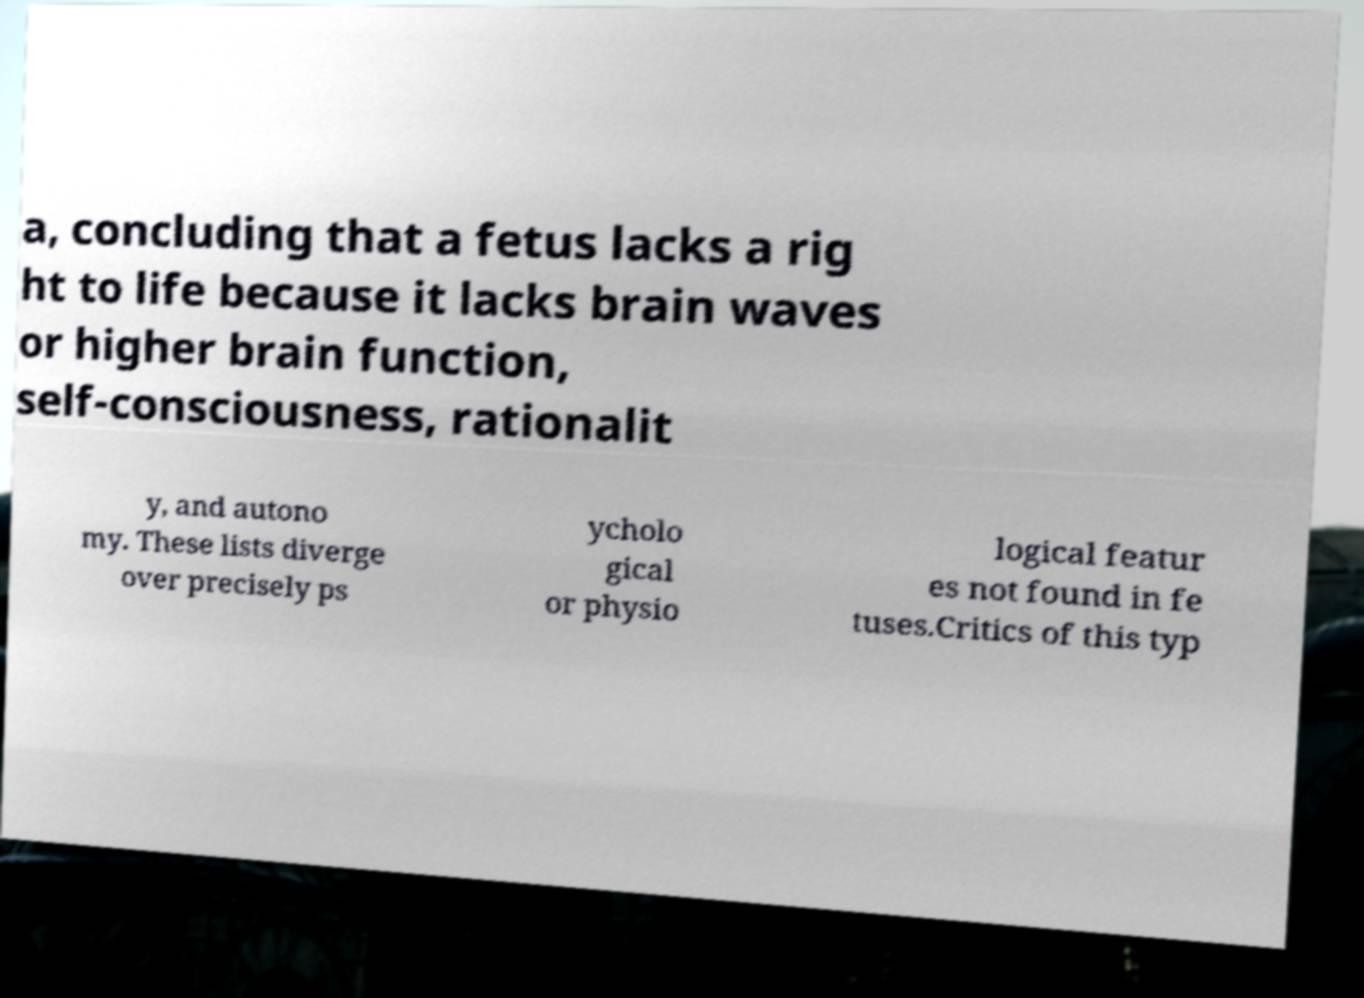Can you accurately transcribe the text from the provided image for me? a, concluding that a fetus lacks a rig ht to life because it lacks brain waves or higher brain function, self-consciousness, rationalit y, and autono my. These lists diverge over precisely ps ycholo gical or physio logical featur es not found in fe tuses.Critics of this typ 